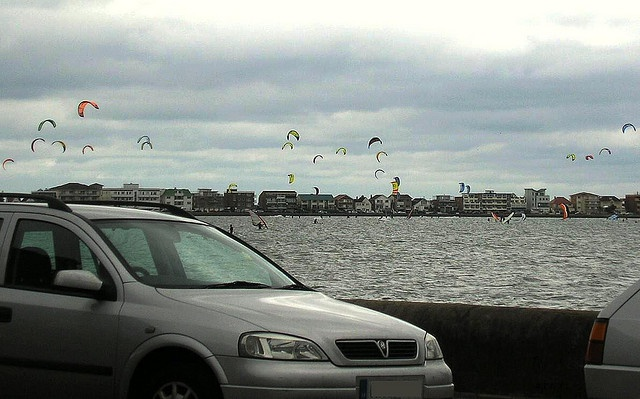Describe the objects in this image and their specific colors. I can see car in lightgray, black, gray, darkgray, and beige tones, car in lightgray, black, gray, and darkgray tones, kite in lightgray, darkgray, and black tones, kite in lightgray, brown, black, maroon, and salmon tones, and kite in lightgray, gray, black, beige, and darkgray tones in this image. 